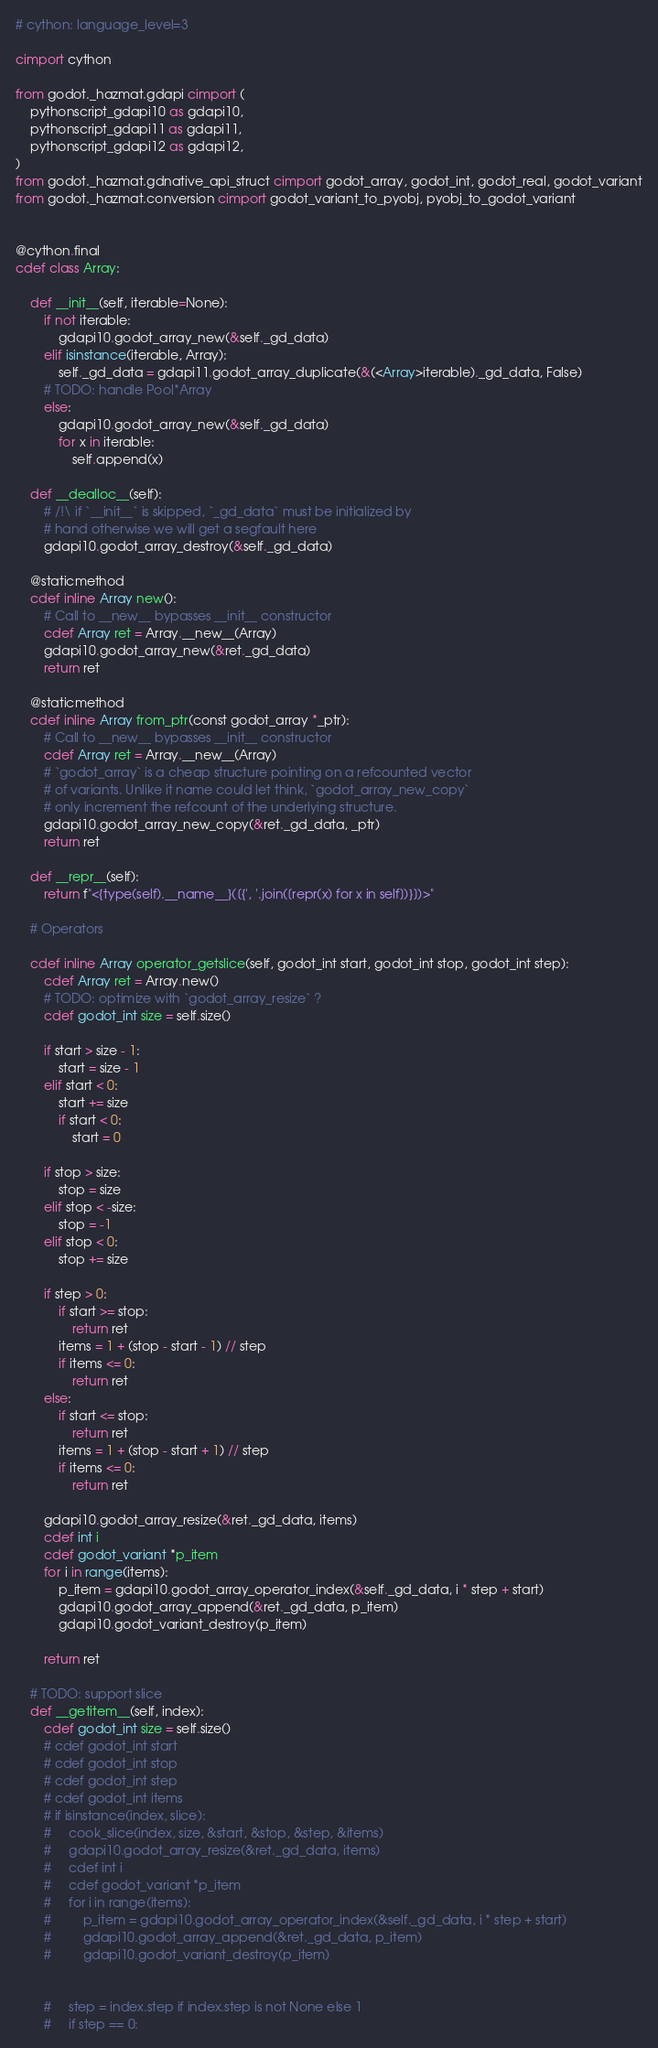<code> <loc_0><loc_0><loc_500><loc_500><_Cython_># cython: language_level=3

cimport cython

from godot._hazmat.gdapi cimport (
    pythonscript_gdapi10 as gdapi10,
    pythonscript_gdapi11 as gdapi11,
    pythonscript_gdapi12 as gdapi12,
)
from godot._hazmat.gdnative_api_struct cimport godot_array, godot_int, godot_real, godot_variant
from godot._hazmat.conversion cimport godot_variant_to_pyobj, pyobj_to_godot_variant


@cython.final
cdef class Array:

    def __init__(self, iterable=None):
        if not iterable:
            gdapi10.godot_array_new(&self._gd_data)
        elif isinstance(iterable, Array):
            self._gd_data = gdapi11.godot_array_duplicate(&(<Array>iterable)._gd_data, False)
        # TODO: handle Pool*Array
        else:
            gdapi10.godot_array_new(&self._gd_data)
            for x in iterable:
                self.append(x)

    def __dealloc__(self):
        # /!\ if `__init__` is skipped, `_gd_data` must be initialized by
        # hand otherwise we will get a segfault here
        gdapi10.godot_array_destroy(&self._gd_data)

    @staticmethod
    cdef inline Array new():
        # Call to __new__ bypasses __init__ constructor
        cdef Array ret = Array.__new__(Array)
        gdapi10.godot_array_new(&ret._gd_data)
        return ret

    @staticmethod
    cdef inline Array from_ptr(const godot_array *_ptr):
        # Call to __new__ bypasses __init__ constructor
        cdef Array ret = Array.__new__(Array)
        # `godot_array` is a cheap structure pointing on a refcounted vector
        # of variants. Unlike it name could let think, `godot_array_new_copy`
        # only increment the refcount of the underlying structure.
        gdapi10.godot_array_new_copy(&ret._gd_data, _ptr)
        return ret

    def __repr__(self):
        return f"<{type(self).__name__}([{', '.join([repr(x) for x in self])}])>"

    # Operators

    cdef inline Array operator_getslice(self, godot_int start, godot_int stop, godot_int step):
        cdef Array ret = Array.new()
        # TODO: optimize with `godot_array_resize` ?
        cdef godot_int size = self.size()

        if start > size - 1:
            start = size - 1
        elif start < 0:
            start += size
            if start < 0:
                start = 0

        if stop > size:
            stop = size
        elif stop < -size:
            stop = -1
        elif stop < 0:
            stop += size

        if step > 0:
            if start >= stop:
                return ret
            items = 1 + (stop - start - 1) // step
            if items <= 0:
                return ret
        else:
            if start <= stop:
                return ret
            items = 1 + (stop - start + 1) // step
            if items <= 0:
                return ret

        gdapi10.godot_array_resize(&ret._gd_data, items)
        cdef int i
        cdef godot_variant *p_item
        for i in range(items):
            p_item = gdapi10.godot_array_operator_index(&self._gd_data, i * step + start)
            gdapi10.godot_array_append(&ret._gd_data, p_item)
            gdapi10.godot_variant_destroy(p_item)

        return ret

    # TODO: support slice
    def __getitem__(self, index):
        cdef godot_int size = self.size()
        # cdef godot_int start
        # cdef godot_int stop
        # cdef godot_int step
        # cdef godot_int items
        # if isinstance(index, slice):
        #     cook_slice(index, size, &start, &stop, &step, &items)
        #     gdapi10.godot_array_resize(&ret._gd_data, items)
        #     cdef int i
        #     cdef godot_variant *p_item
        #     for i in range(items):
        #         p_item = gdapi10.godot_array_operator_index(&self._gd_data, i * step + start)
        #         gdapi10.godot_array_append(&ret._gd_data, p_item)
        #         gdapi10.godot_variant_destroy(p_item)


        #     step = index.step if index.step is not None else 1
        #     if step == 0:</code> 